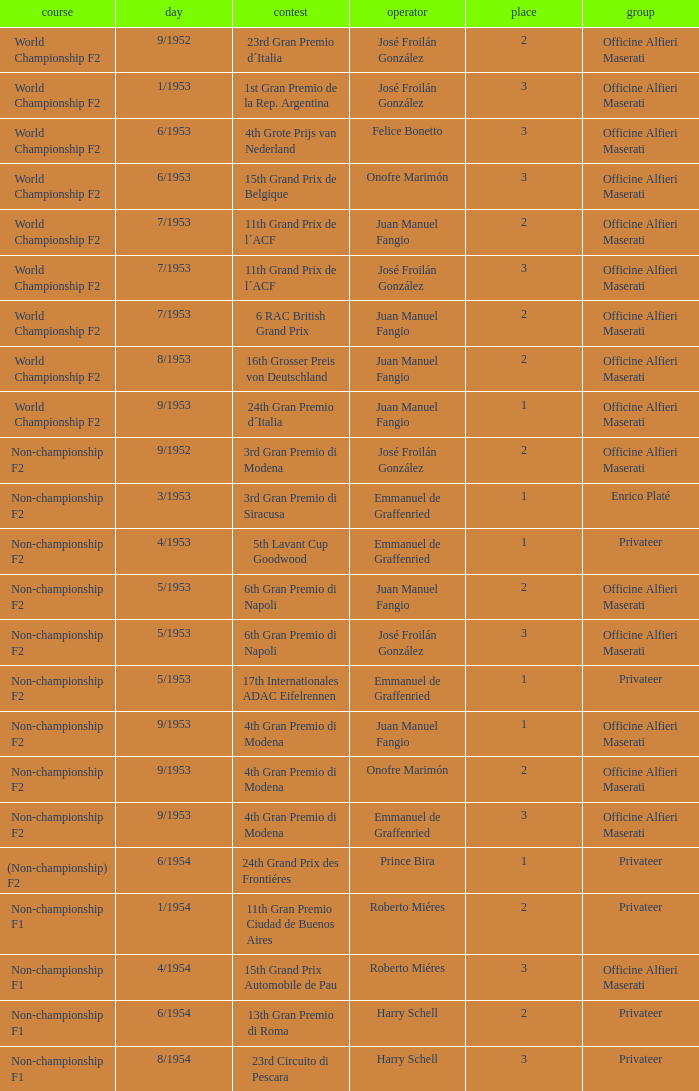What class has the date of 8/1954? Non-championship F1. 